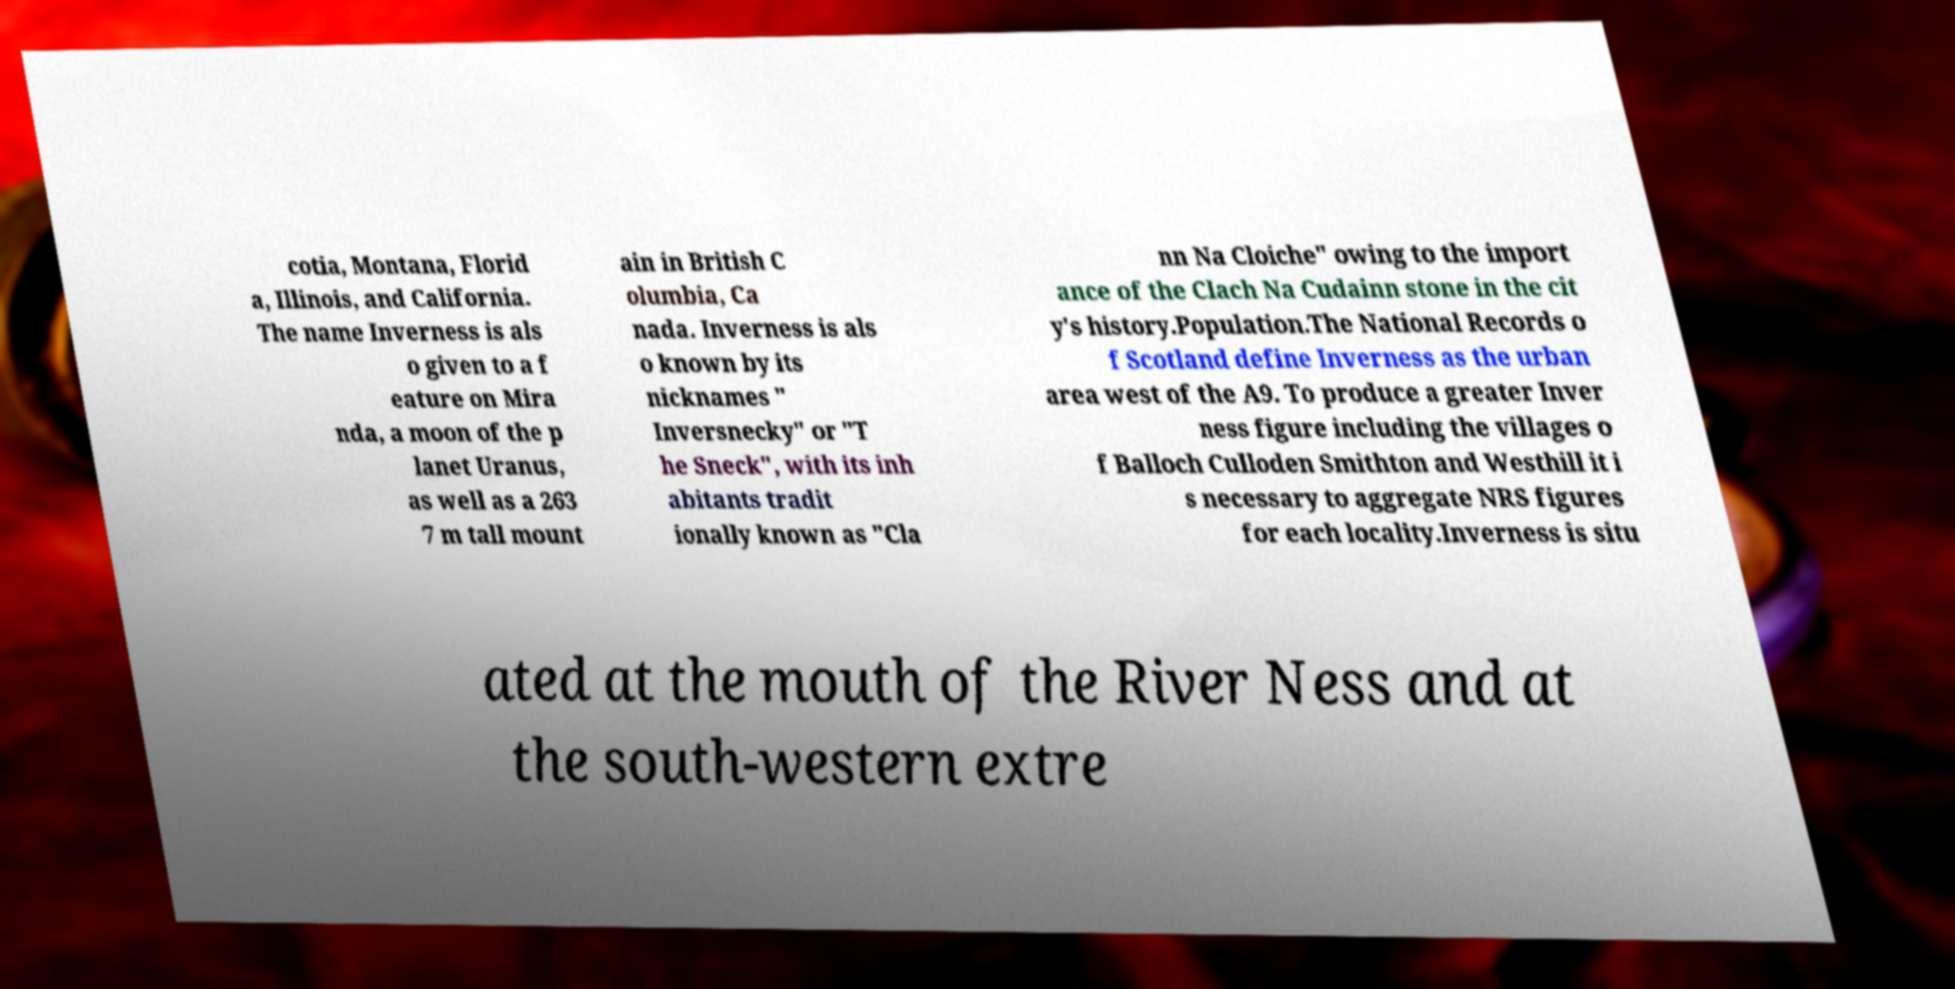Please read and relay the text visible in this image. What does it say? cotia, Montana, Florid a, Illinois, and California. The name Inverness is als o given to a f eature on Mira nda, a moon of the p lanet Uranus, as well as a 263 7 m tall mount ain in British C olumbia, Ca nada. Inverness is als o known by its nicknames " Inversnecky" or "T he Sneck", with its inh abitants tradit ionally known as "Cla nn Na Cloiche" owing to the import ance of the Clach Na Cudainn stone in the cit y's history.Population.The National Records o f Scotland define Inverness as the urban area west of the A9. To produce a greater Inver ness figure including the villages o f Balloch Culloden Smithton and Westhill it i s necessary to aggregate NRS figures for each locality.Inverness is situ ated at the mouth of the River Ness and at the south-western extre 